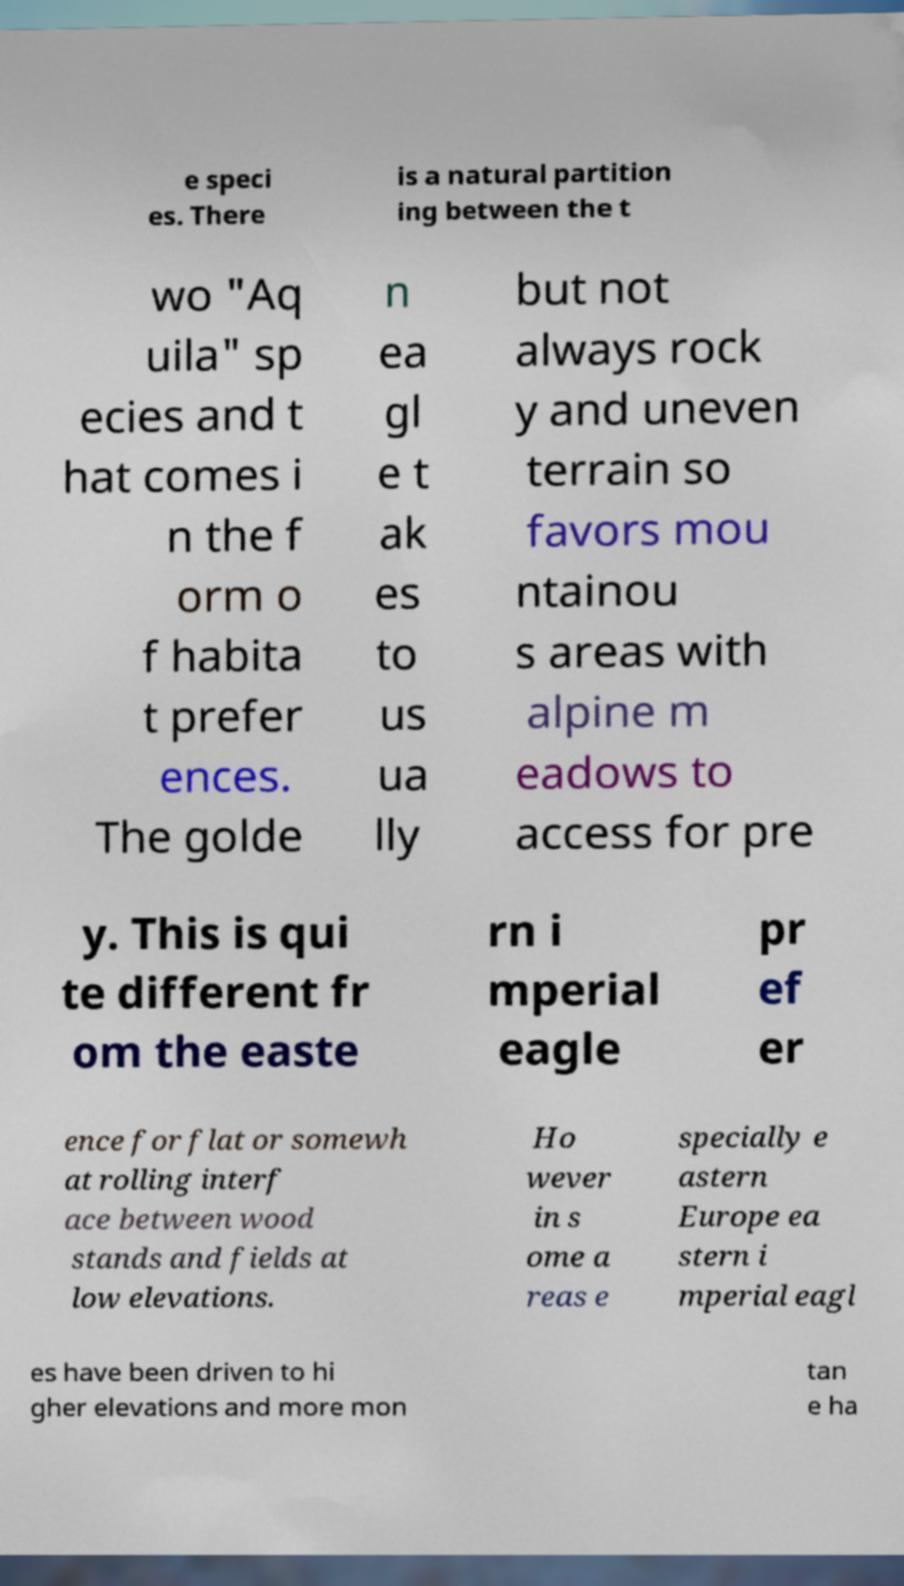Could you assist in decoding the text presented in this image and type it out clearly? e speci es. There is a natural partition ing between the t wo "Aq uila" sp ecies and t hat comes i n the f orm o f habita t prefer ences. The golde n ea gl e t ak es to us ua lly but not always rock y and uneven terrain so favors mou ntainou s areas with alpine m eadows to access for pre y. This is qui te different fr om the easte rn i mperial eagle pr ef er ence for flat or somewh at rolling interf ace between wood stands and fields at low elevations. Ho wever in s ome a reas e specially e astern Europe ea stern i mperial eagl es have been driven to hi gher elevations and more mon tan e ha 